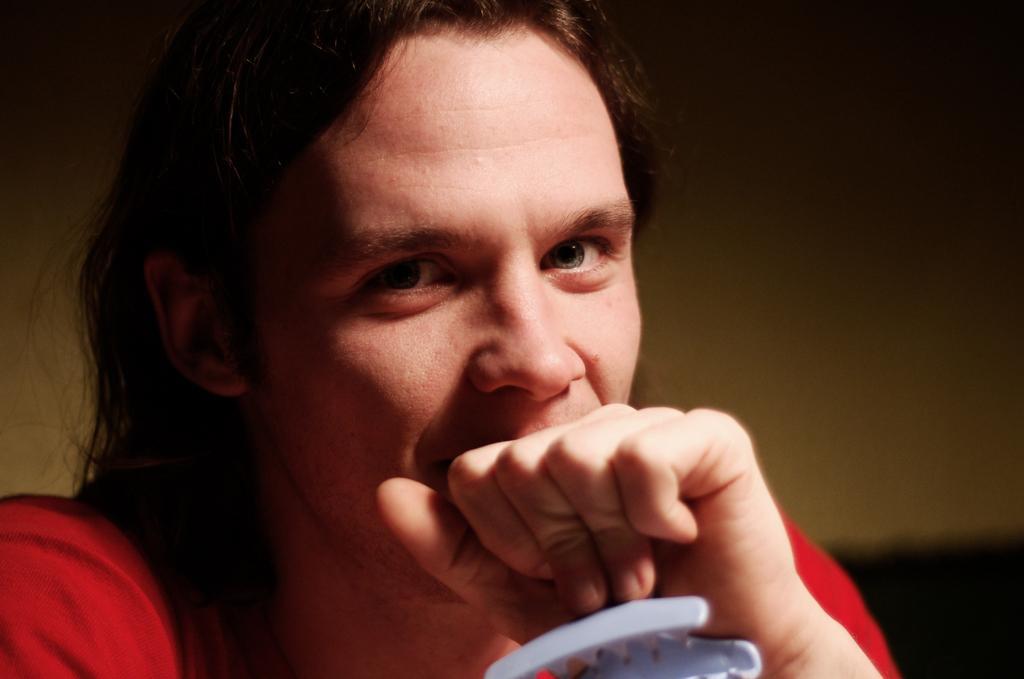Can you describe this image briefly? In this image I can see a person holding something. In the background, I can see the wall. 